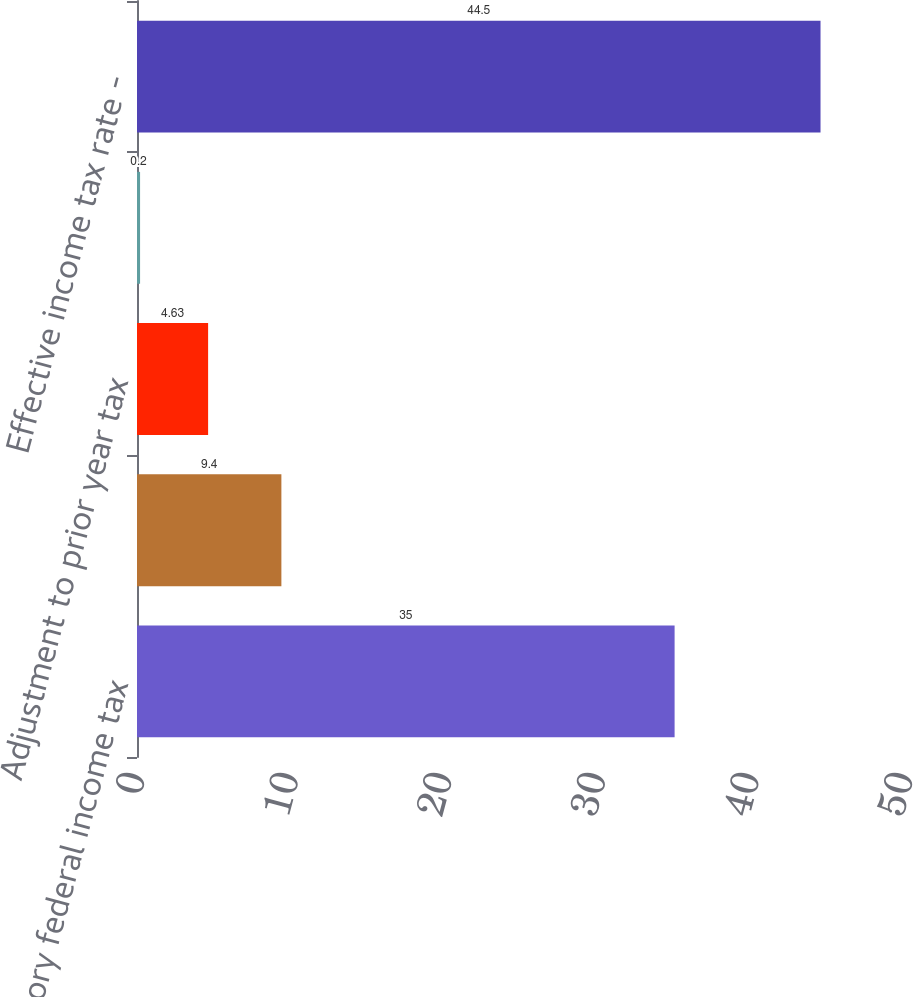Convert chart to OTSL. <chart><loc_0><loc_0><loc_500><loc_500><bar_chart><fcel>Statutory federal income tax<fcel>Tax-exempt income<fcel>Adjustment to prior year tax<fcel>Other<fcel>Effective income tax rate -<nl><fcel>35<fcel>9.4<fcel>4.63<fcel>0.2<fcel>44.5<nl></chart> 